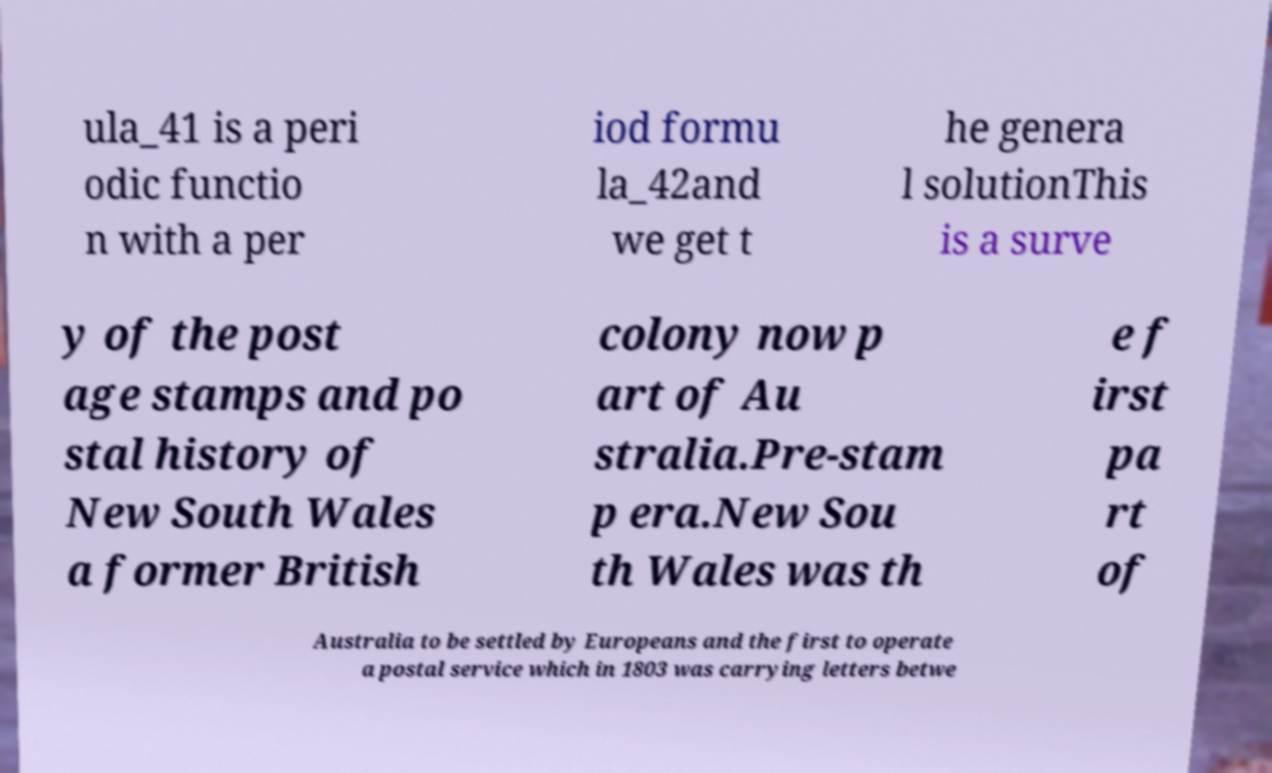Can you read and provide the text displayed in the image?This photo seems to have some interesting text. Can you extract and type it out for me? ula_41 is a peri odic functio n with a per iod formu la_42and we get t he genera l solutionThis is a surve y of the post age stamps and po stal history of New South Wales a former British colony now p art of Au stralia.Pre-stam p era.New Sou th Wales was th e f irst pa rt of Australia to be settled by Europeans and the first to operate a postal service which in 1803 was carrying letters betwe 